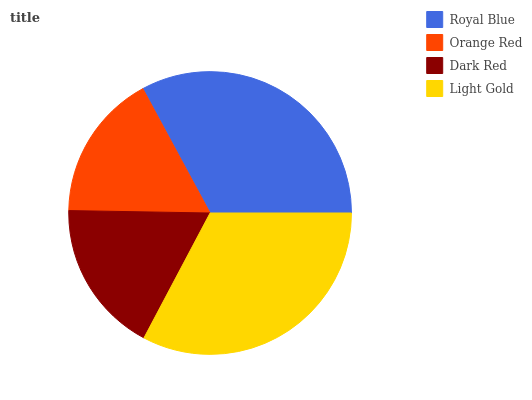Is Orange Red the minimum?
Answer yes or no. Yes. Is Royal Blue the maximum?
Answer yes or no. Yes. Is Dark Red the minimum?
Answer yes or no. No. Is Dark Red the maximum?
Answer yes or no. No. Is Dark Red greater than Orange Red?
Answer yes or no. Yes. Is Orange Red less than Dark Red?
Answer yes or no. Yes. Is Orange Red greater than Dark Red?
Answer yes or no. No. Is Dark Red less than Orange Red?
Answer yes or no. No. Is Light Gold the high median?
Answer yes or no. Yes. Is Dark Red the low median?
Answer yes or no. Yes. Is Orange Red the high median?
Answer yes or no. No. Is Royal Blue the low median?
Answer yes or no. No. 